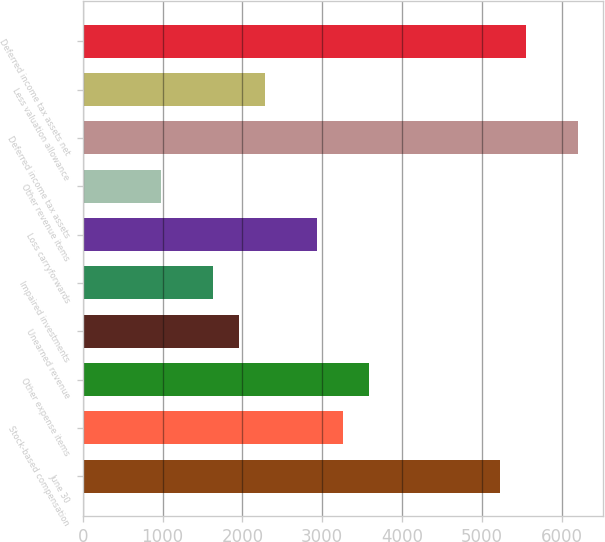<chart> <loc_0><loc_0><loc_500><loc_500><bar_chart><fcel>June 30<fcel>Stock-based compensation<fcel>Other expense items<fcel>Unearned revenue<fcel>Impaired investments<fcel>Loss carryforwards<fcel>Other revenue items<fcel>Deferred income tax assets<fcel>Less valuation allowance<fcel>Deferred income tax assets net<nl><fcel>5224.4<fcel>3266<fcel>3592.4<fcel>1960.4<fcel>1634<fcel>2939.6<fcel>981.2<fcel>6203.6<fcel>2286.8<fcel>5550.8<nl></chart> 